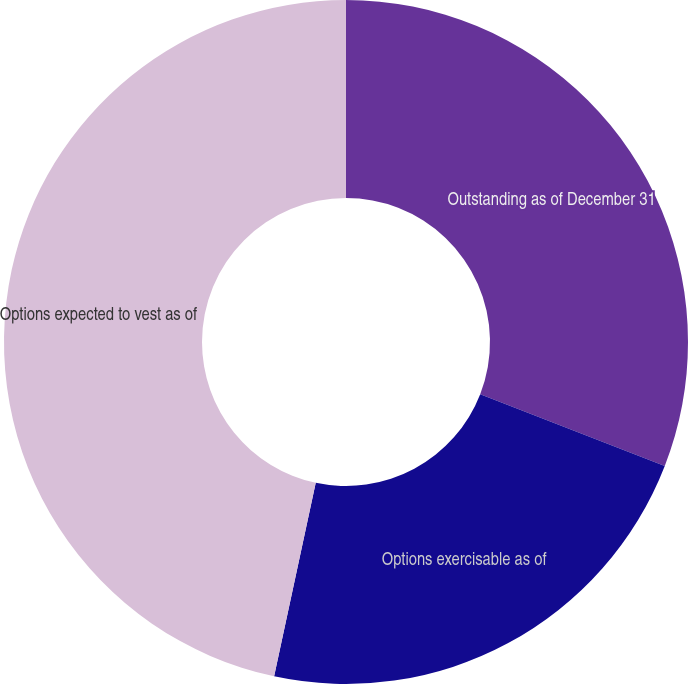Convert chart. <chart><loc_0><loc_0><loc_500><loc_500><pie_chart><fcel>Outstanding as of December 31<fcel>Options exercisable as of<fcel>Options expected to vest as of<nl><fcel>30.9%<fcel>22.47%<fcel>46.63%<nl></chart> 